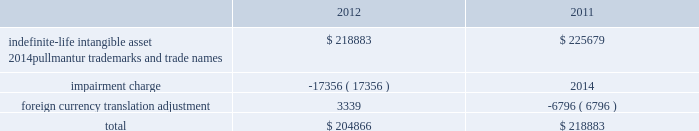Notes to the consolidated financial statements competitive environment and general economic and business conditions , among other factors .
Pullmantur is a brand targeted primarily at the spanish , portu- guese and latin american markets and although pullmantur has diversified its passenger sourcing over the past few years , spain still represents pullmantur 2019s largest market .
As previously disclosed , during 2012 european economies continued to demonstrate insta- bility in light of heightened concerns over sovereign debt issues as well as the impact of proposed auster- ity measures on certain markets .
The spanish econ- omy was more severely impacted than many other economies and there is significant uncertainty as to when it will recover .
In addition , the impact of the costa concordia incident has had a more lingering effect than expected and the impact in future years is uncertain .
These factors were identified in the past as significant risks which could lead to the impairment of pullmantur 2019s goodwill .
More recently , the spanish economy has progressively worsened and forecasts suggest the challenging operating environment will continue for an extended period of time .
The unemployment rate in spain reached 26% ( 26 % ) during the fourth quarter of 2012 and is expected to rise further in 2013 .
The international monetary fund , which had projected gdp growth of 1.8% ( 1.8 % ) a year ago , revised its 2013 gdp projections downward for spain to a contraction of 1.3% ( 1.3 % ) during the fourth quarter of 2012 and further reduced it to a contraction of 1.5% ( 1.5 % ) in january of 2013 .
During the latter half of 2012 new austerity measures , such as increases to the value added tax , cuts to benefits , the phasing out of exemptions and the suspension of government bonuses , were implemented by the spanish government .
We believe these austerity measures are having a larger impact on consumer confidence and discretionary spending than previously anticipated .
As a result , there has been a significant deterioration in bookings from guests sourced from spain during the 2013 wave season .
The combination of all of these factors has caused us to negatively adjust our cash flow projections , especially our closer-in net yield assumptions and the expectations regarding future capacity growth for the brand .
Based on our updated cash flow projections , we determined the implied fair value of goodwill for the pullmantur reporting unit was $ 145.5 million and rec- ognized an impairment charge of $ 319.2 million .
This impairment charge was recognized in earnings during the fourth quarter of 2012 and is reported within impairment of pullmantur related assets within our consolidated statements of comprehensive income ( loss ) .
There have been no goodwill impairment charges related to the pullmantur reporting unit in prior periods .
See note 13 .
Fair value measurements and derivative instruments for further discussion .
If the spanish economy weakens further or recovers more slowly than contemplated or if the economies of other markets ( e.g .
France , brazil , latin america ) perform worse than contemplated in our discounted cash flow model , or if there are material changes to the projected future cash flows used in the impair- ment analyses , especially in net yields , an additional impairment charge of the pullmantur reporting unit 2019s goodwill may be required .
Note 4 .
Intangible assets intangible assets are reported in other assets in our consolidated balance sheets and consist of the follow- ing ( in thousands ) : .
During the fourth quarter of 2012 , we performed the annual impairment review of our trademarks and trade names using a discounted cash flow model and the relief-from-royalty method .
The royalty rate used is based on comparable royalty agreements in the tourism and hospitality industry .
These trademarks and trade names relate to pullmantur and we have used a discount rate comparable to the rate used in valuing the pullmantur reporting unit in our goodwill impairment test .
As described in note 3 .
Goodwill , the continued deterioration of the spanish economy caused us to negatively adjust our cash flow projections for the pullmantur reporting unit , especially our closer-in net yield assumptions and the timing of future capacity growth for the brand .
Based on our updated cash flow projections , we determined that the fair value of pullmantur 2019s trademarks and trade names no longer exceeded their carrying value .
Accordingly , we recog- nized an impairment charge of approximately $ 17.4 million to write down trademarks and trade names to their fair value of $ 204.9 million .
This impairment charge was recognized in earnings during the fourth quarter of 2012 and is reported within impairment of pullmantur related assets within our consolidated statements of comprehensive income ( loss ) .
See note 13 .
Fair value measurements and derivative instruments for further discussion .
If the spanish economy weakens further or recovers more slowly than contemplated or if the economies of other markets ( e.g .
France , brazil , latin america ) 0494.indd 76 3/27/13 12:53 pm .
What was the percentage decline in the value of the intangible assets from 2011 to 2012? 
Computations: ((204866 - 218883) / 218883)
Answer: -0.06404. 